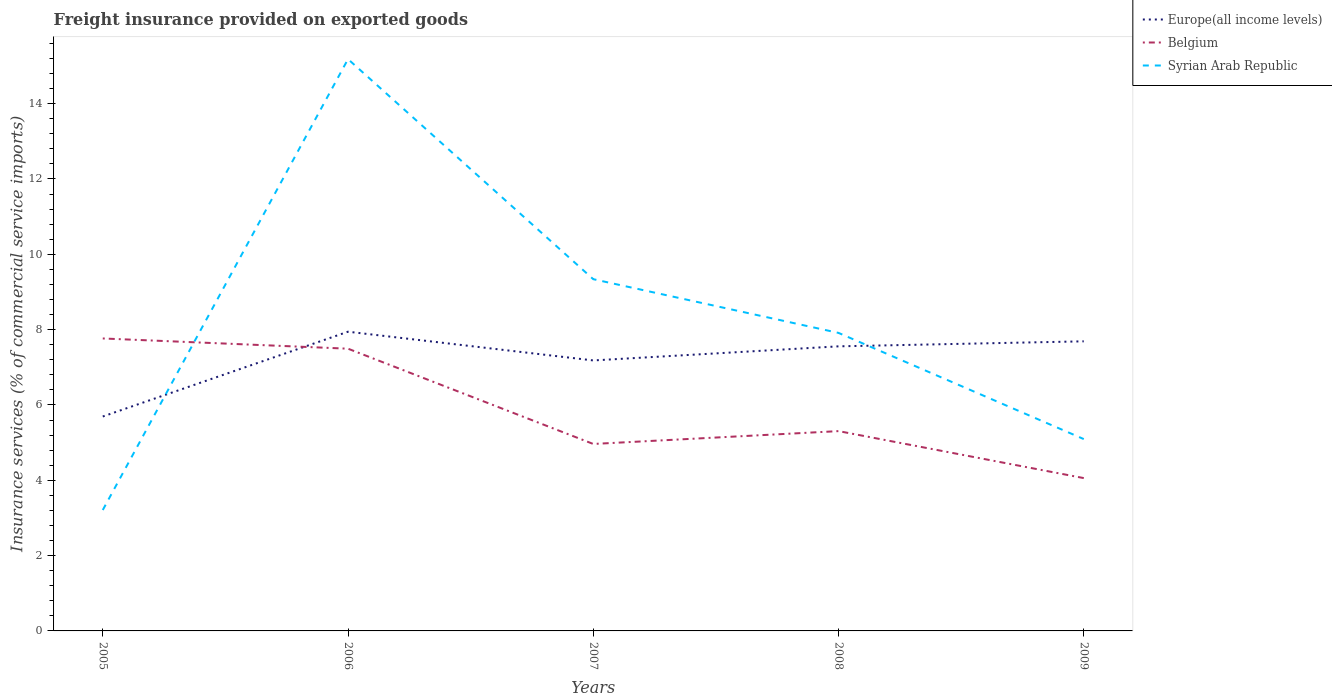How many different coloured lines are there?
Provide a short and direct response. 3. Does the line corresponding to Syrian Arab Republic intersect with the line corresponding to Belgium?
Your answer should be compact. Yes. Across all years, what is the maximum freight insurance provided on exported goods in Europe(all income levels)?
Offer a very short reply. 5.69. What is the total freight insurance provided on exported goods in Belgium in the graph?
Provide a succinct answer. 3.44. What is the difference between the highest and the second highest freight insurance provided on exported goods in Syrian Arab Republic?
Give a very brief answer. 11.97. Is the freight insurance provided on exported goods in Europe(all income levels) strictly greater than the freight insurance provided on exported goods in Syrian Arab Republic over the years?
Give a very brief answer. No. What is the difference between two consecutive major ticks on the Y-axis?
Your response must be concise. 2. Are the values on the major ticks of Y-axis written in scientific E-notation?
Give a very brief answer. No. Does the graph contain grids?
Keep it short and to the point. No. Where does the legend appear in the graph?
Your response must be concise. Top right. What is the title of the graph?
Provide a succinct answer. Freight insurance provided on exported goods. Does "Bangladesh" appear as one of the legend labels in the graph?
Your answer should be very brief. No. What is the label or title of the X-axis?
Your answer should be very brief. Years. What is the label or title of the Y-axis?
Ensure brevity in your answer.  Insurance services (% of commercial service imports). What is the Insurance services (% of commercial service imports) in Europe(all income levels) in 2005?
Give a very brief answer. 5.69. What is the Insurance services (% of commercial service imports) in Belgium in 2005?
Ensure brevity in your answer.  7.77. What is the Insurance services (% of commercial service imports) in Syrian Arab Republic in 2005?
Provide a succinct answer. 3.21. What is the Insurance services (% of commercial service imports) in Europe(all income levels) in 2006?
Offer a terse response. 7.94. What is the Insurance services (% of commercial service imports) in Belgium in 2006?
Offer a terse response. 7.49. What is the Insurance services (% of commercial service imports) in Syrian Arab Republic in 2006?
Your response must be concise. 15.18. What is the Insurance services (% of commercial service imports) of Europe(all income levels) in 2007?
Ensure brevity in your answer.  7.18. What is the Insurance services (% of commercial service imports) of Belgium in 2007?
Keep it short and to the point. 4.96. What is the Insurance services (% of commercial service imports) of Syrian Arab Republic in 2007?
Offer a very short reply. 9.34. What is the Insurance services (% of commercial service imports) in Europe(all income levels) in 2008?
Your answer should be very brief. 7.56. What is the Insurance services (% of commercial service imports) of Belgium in 2008?
Provide a short and direct response. 5.31. What is the Insurance services (% of commercial service imports) of Syrian Arab Republic in 2008?
Your response must be concise. 7.91. What is the Insurance services (% of commercial service imports) in Europe(all income levels) in 2009?
Your answer should be compact. 7.69. What is the Insurance services (% of commercial service imports) in Belgium in 2009?
Provide a succinct answer. 4.06. What is the Insurance services (% of commercial service imports) in Syrian Arab Republic in 2009?
Provide a succinct answer. 5.09. Across all years, what is the maximum Insurance services (% of commercial service imports) in Europe(all income levels)?
Your answer should be compact. 7.94. Across all years, what is the maximum Insurance services (% of commercial service imports) of Belgium?
Ensure brevity in your answer.  7.77. Across all years, what is the maximum Insurance services (% of commercial service imports) in Syrian Arab Republic?
Give a very brief answer. 15.18. Across all years, what is the minimum Insurance services (% of commercial service imports) in Europe(all income levels)?
Your answer should be very brief. 5.69. Across all years, what is the minimum Insurance services (% of commercial service imports) of Belgium?
Offer a terse response. 4.06. Across all years, what is the minimum Insurance services (% of commercial service imports) in Syrian Arab Republic?
Keep it short and to the point. 3.21. What is the total Insurance services (% of commercial service imports) in Europe(all income levels) in the graph?
Your answer should be compact. 36.07. What is the total Insurance services (% of commercial service imports) in Belgium in the graph?
Your answer should be compact. 29.59. What is the total Insurance services (% of commercial service imports) of Syrian Arab Republic in the graph?
Offer a very short reply. 40.74. What is the difference between the Insurance services (% of commercial service imports) of Europe(all income levels) in 2005 and that in 2006?
Give a very brief answer. -2.25. What is the difference between the Insurance services (% of commercial service imports) in Belgium in 2005 and that in 2006?
Offer a very short reply. 0.27. What is the difference between the Insurance services (% of commercial service imports) in Syrian Arab Republic in 2005 and that in 2006?
Provide a short and direct response. -11.97. What is the difference between the Insurance services (% of commercial service imports) of Europe(all income levels) in 2005 and that in 2007?
Provide a succinct answer. -1.49. What is the difference between the Insurance services (% of commercial service imports) in Belgium in 2005 and that in 2007?
Your response must be concise. 2.8. What is the difference between the Insurance services (% of commercial service imports) of Syrian Arab Republic in 2005 and that in 2007?
Offer a terse response. -6.13. What is the difference between the Insurance services (% of commercial service imports) in Europe(all income levels) in 2005 and that in 2008?
Ensure brevity in your answer.  -1.86. What is the difference between the Insurance services (% of commercial service imports) in Belgium in 2005 and that in 2008?
Your answer should be very brief. 2.46. What is the difference between the Insurance services (% of commercial service imports) of Syrian Arab Republic in 2005 and that in 2008?
Offer a terse response. -4.7. What is the difference between the Insurance services (% of commercial service imports) in Europe(all income levels) in 2005 and that in 2009?
Provide a short and direct response. -2. What is the difference between the Insurance services (% of commercial service imports) of Belgium in 2005 and that in 2009?
Make the answer very short. 3.71. What is the difference between the Insurance services (% of commercial service imports) in Syrian Arab Republic in 2005 and that in 2009?
Offer a very short reply. -1.88. What is the difference between the Insurance services (% of commercial service imports) in Europe(all income levels) in 2006 and that in 2007?
Offer a terse response. 0.76. What is the difference between the Insurance services (% of commercial service imports) of Belgium in 2006 and that in 2007?
Your answer should be compact. 2.53. What is the difference between the Insurance services (% of commercial service imports) of Syrian Arab Republic in 2006 and that in 2007?
Your answer should be compact. 5.84. What is the difference between the Insurance services (% of commercial service imports) of Europe(all income levels) in 2006 and that in 2008?
Offer a terse response. 0.39. What is the difference between the Insurance services (% of commercial service imports) in Belgium in 2006 and that in 2008?
Offer a terse response. 2.19. What is the difference between the Insurance services (% of commercial service imports) in Syrian Arab Republic in 2006 and that in 2008?
Offer a terse response. 7.27. What is the difference between the Insurance services (% of commercial service imports) of Europe(all income levels) in 2006 and that in 2009?
Your answer should be very brief. 0.26. What is the difference between the Insurance services (% of commercial service imports) in Belgium in 2006 and that in 2009?
Your answer should be compact. 3.44. What is the difference between the Insurance services (% of commercial service imports) of Syrian Arab Republic in 2006 and that in 2009?
Offer a very short reply. 10.09. What is the difference between the Insurance services (% of commercial service imports) of Europe(all income levels) in 2007 and that in 2008?
Your answer should be very brief. -0.37. What is the difference between the Insurance services (% of commercial service imports) in Belgium in 2007 and that in 2008?
Your answer should be compact. -0.34. What is the difference between the Insurance services (% of commercial service imports) of Syrian Arab Republic in 2007 and that in 2008?
Your answer should be very brief. 1.43. What is the difference between the Insurance services (% of commercial service imports) of Europe(all income levels) in 2007 and that in 2009?
Give a very brief answer. -0.51. What is the difference between the Insurance services (% of commercial service imports) of Belgium in 2007 and that in 2009?
Give a very brief answer. 0.91. What is the difference between the Insurance services (% of commercial service imports) in Syrian Arab Republic in 2007 and that in 2009?
Your answer should be very brief. 4.25. What is the difference between the Insurance services (% of commercial service imports) in Europe(all income levels) in 2008 and that in 2009?
Make the answer very short. -0.13. What is the difference between the Insurance services (% of commercial service imports) in Belgium in 2008 and that in 2009?
Offer a very short reply. 1.25. What is the difference between the Insurance services (% of commercial service imports) in Syrian Arab Republic in 2008 and that in 2009?
Make the answer very short. 2.82. What is the difference between the Insurance services (% of commercial service imports) of Europe(all income levels) in 2005 and the Insurance services (% of commercial service imports) of Belgium in 2006?
Provide a short and direct response. -1.8. What is the difference between the Insurance services (% of commercial service imports) in Europe(all income levels) in 2005 and the Insurance services (% of commercial service imports) in Syrian Arab Republic in 2006?
Offer a very short reply. -9.49. What is the difference between the Insurance services (% of commercial service imports) in Belgium in 2005 and the Insurance services (% of commercial service imports) in Syrian Arab Republic in 2006?
Keep it short and to the point. -7.42. What is the difference between the Insurance services (% of commercial service imports) in Europe(all income levels) in 2005 and the Insurance services (% of commercial service imports) in Belgium in 2007?
Offer a terse response. 0.73. What is the difference between the Insurance services (% of commercial service imports) of Europe(all income levels) in 2005 and the Insurance services (% of commercial service imports) of Syrian Arab Republic in 2007?
Give a very brief answer. -3.65. What is the difference between the Insurance services (% of commercial service imports) of Belgium in 2005 and the Insurance services (% of commercial service imports) of Syrian Arab Republic in 2007?
Provide a succinct answer. -1.57. What is the difference between the Insurance services (% of commercial service imports) in Europe(all income levels) in 2005 and the Insurance services (% of commercial service imports) in Belgium in 2008?
Provide a short and direct response. 0.39. What is the difference between the Insurance services (% of commercial service imports) in Europe(all income levels) in 2005 and the Insurance services (% of commercial service imports) in Syrian Arab Republic in 2008?
Your answer should be compact. -2.22. What is the difference between the Insurance services (% of commercial service imports) of Belgium in 2005 and the Insurance services (% of commercial service imports) of Syrian Arab Republic in 2008?
Your answer should be very brief. -0.15. What is the difference between the Insurance services (% of commercial service imports) in Europe(all income levels) in 2005 and the Insurance services (% of commercial service imports) in Belgium in 2009?
Keep it short and to the point. 1.64. What is the difference between the Insurance services (% of commercial service imports) of Europe(all income levels) in 2005 and the Insurance services (% of commercial service imports) of Syrian Arab Republic in 2009?
Keep it short and to the point. 0.6. What is the difference between the Insurance services (% of commercial service imports) in Belgium in 2005 and the Insurance services (% of commercial service imports) in Syrian Arab Republic in 2009?
Offer a terse response. 2.67. What is the difference between the Insurance services (% of commercial service imports) in Europe(all income levels) in 2006 and the Insurance services (% of commercial service imports) in Belgium in 2007?
Give a very brief answer. 2.98. What is the difference between the Insurance services (% of commercial service imports) in Europe(all income levels) in 2006 and the Insurance services (% of commercial service imports) in Syrian Arab Republic in 2007?
Keep it short and to the point. -1.39. What is the difference between the Insurance services (% of commercial service imports) of Belgium in 2006 and the Insurance services (% of commercial service imports) of Syrian Arab Republic in 2007?
Ensure brevity in your answer.  -1.85. What is the difference between the Insurance services (% of commercial service imports) in Europe(all income levels) in 2006 and the Insurance services (% of commercial service imports) in Belgium in 2008?
Your answer should be very brief. 2.64. What is the difference between the Insurance services (% of commercial service imports) in Europe(all income levels) in 2006 and the Insurance services (% of commercial service imports) in Syrian Arab Republic in 2008?
Keep it short and to the point. 0.03. What is the difference between the Insurance services (% of commercial service imports) of Belgium in 2006 and the Insurance services (% of commercial service imports) of Syrian Arab Republic in 2008?
Make the answer very short. -0.42. What is the difference between the Insurance services (% of commercial service imports) in Europe(all income levels) in 2006 and the Insurance services (% of commercial service imports) in Belgium in 2009?
Your answer should be compact. 3.89. What is the difference between the Insurance services (% of commercial service imports) of Europe(all income levels) in 2006 and the Insurance services (% of commercial service imports) of Syrian Arab Republic in 2009?
Your answer should be very brief. 2.85. What is the difference between the Insurance services (% of commercial service imports) of Belgium in 2006 and the Insurance services (% of commercial service imports) of Syrian Arab Republic in 2009?
Your answer should be compact. 2.4. What is the difference between the Insurance services (% of commercial service imports) of Europe(all income levels) in 2007 and the Insurance services (% of commercial service imports) of Belgium in 2008?
Your response must be concise. 1.88. What is the difference between the Insurance services (% of commercial service imports) in Europe(all income levels) in 2007 and the Insurance services (% of commercial service imports) in Syrian Arab Republic in 2008?
Provide a short and direct response. -0.73. What is the difference between the Insurance services (% of commercial service imports) in Belgium in 2007 and the Insurance services (% of commercial service imports) in Syrian Arab Republic in 2008?
Provide a short and direct response. -2.95. What is the difference between the Insurance services (% of commercial service imports) of Europe(all income levels) in 2007 and the Insurance services (% of commercial service imports) of Belgium in 2009?
Offer a terse response. 3.12. What is the difference between the Insurance services (% of commercial service imports) in Europe(all income levels) in 2007 and the Insurance services (% of commercial service imports) in Syrian Arab Republic in 2009?
Your response must be concise. 2.09. What is the difference between the Insurance services (% of commercial service imports) in Belgium in 2007 and the Insurance services (% of commercial service imports) in Syrian Arab Republic in 2009?
Your response must be concise. -0.13. What is the difference between the Insurance services (% of commercial service imports) in Europe(all income levels) in 2008 and the Insurance services (% of commercial service imports) in Belgium in 2009?
Provide a succinct answer. 3.5. What is the difference between the Insurance services (% of commercial service imports) of Europe(all income levels) in 2008 and the Insurance services (% of commercial service imports) of Syrian Arab Republic in 2009?
Give a very brief answer. 2.46. What is the difference between the Insurance services (% of commercial service imports) in Belgium in 2008 and the Insurance services (% of commercial service imports) in Syrian Arab Republic in 2009?
Provide a succinct answer. 0.21. What is the average Insurance services (% of commercial service imports) in Europe(all income levels) per year?
Your response must be concise. 7.21. What is the average Insurance services (% of commercial service imports) in Belgium per year?
Your response must be concise. 5.92. What is the average Insurance services (% of commercial service imports) in Syrian Arab Republic per year?
Ensure brevity in your answer.  8.15. In the year 2005, what is the difference between the Insurance services (% of commercial service imports) of Europe(all income levels) and Insurance services (% of commercial service imports) of Belgium?
Offer a terse response. -2.07. In the year 2005, what is the difference between the Insurance services (% of commercial service imports) in Europe(all income levels) and Insurance services (% of commercial service imports) in Syrian Arab Republic?
Make the answer very short. 2.48. In the year 2005, what is the difference between the Insurance services (% of commercial service imports) of Belgium and Insurance services (% of commercial service imports) of Syrian Arab Republic?
Make the answer very short. 4.56. In the year 2006, what is the difference between the Insurance services (% of commercial service imports) in Europe(all income levels) and Insurance services (% of commercial service imports) in Belgium?
Provide a short and direct response. 0.45. In the year 2006, what is the difference between the Insurance services (% of commercial service imports) in Europe(all income levels) and Insurance services (% of commercial service imports) in Syrian Arab Republic?
Make the answer very short. -7.24. In the year 2006, what is the difference between the Insurance services (% of commercial service imports) of Belgium and Insurance services (% of commercial service imports) of Syrian Arab Republic?
Your response must be concise. -7.69. In the year 2007, what is the difference between the Insurance services (% of commercial service imports) of Europe(all income levels) and Insurance services (% of commercial service imports) of Belgium?
Your response must be concise. 2.22. In the year 2007, what is the difference between the Insurance services (% of commercial service imports) in Europe(all income levels) and Insurance services (% of commercial service imports) in Syrian Arab Republic?
Provide a short and direct response. -2.16. In the year 2007, what is the difference between the Insurance services (% of commercial service imports) in Belgium and Insurance services (% of commercial service imports) in Syrian Arab Republic?
Offer a very short reply. -4.38. In the year 2008, what is the difference between the Insurance services (% of commercial service imports) in Europe(all income levels) and Insurance services (% of commercial service imports) in Belgium?
Ensure brevity in your answer.  2.25. In the year 2008, what is the difference between the Insurance services (% of commercial service imports) in Europe(all income levels) and Insurance services (% of commercial service imports) in Syrian Arab Republic?
Give a very brief answer. -0.36. In the year 2008, what is the difference between the Insurance services (% of commercial service imports) in Belgium and Insurance services (% of commercial service imports) in Syrian Arab Republic?
Give a very brief answer. -2.61. In the year 2009, what is the difference between the Insurance services (% of commercial service imports) in Europe(all income levels) and Insurance services (% of commercial service imports) in Belgium?
Your answer should be very brief. 3.63. In the year 2009, what is the difference between the Insurance services (% of commercial service imports) of Europe(all income levels) and Insurance services (% of commercial service imports) of Syrian Arab Republic?
Provide a short and direct response. 2.6. In the year 2009, what is the difference between the Insurance services (% of commercial service imports) in Belgium and Insurance services (% of commercial service imports) in Syrian Arab Republic?
Offer a very short reply. -1.04. What is the ratio of the Insurance services (% of commercial service imports) of Europe(all income levels) in 2005 to that in 2006?
Give a very brief answer. 0.72. What is the ratio of the Insurance services (% of commercial service imports) in Belgium in 2005 to that in 2006?
Give a very brief answer. 1.04. What is the ratio of the Insurance services (% of commercial service imports) of Syrian Arab Republic in 2005 to that in 2006?
Provide a succinct answer. 0.21. What is the ratio of the Insurance services (% of commercial service imports) in Europe(all income levels) in 2005 to that in 2007?
Your answer should be compact. 0.79. What is the ratio of the Insurance services (% of commercial service imports) in Belgium in 2005 to that in 2007?
Provide a succinct answer. 1.56. What is the ratio of the Insurance services (% of commercial service imports) in Syrian Arab Republic in 2005 to that in 2007?
Your answer should be compact. 0.34. What is the ratio of the Insurance services (% of commercial service imports) of Europe(all income levels) in 2005 to that in 2008?
Offer a very short reply. 0.75. What is the ratio of the Insurance services (% of commercial service imports) in Belgium in 2005 to that in 2008?
Provide a succinct answer. 1.46. What is the ratio of the Insurance services (% of commercial service imports) of Syrian Arab Republic in 2005 to that in 2008?
Provide a succinct answer. 0.41. What is the ratio of the Insurance services (% of commercial service imports) in Europe(all income levels) in 2005 to that in 2009?
Your answer should be compact. 0.74. What is the ratio of the Insurance services (% of commercial service imports) in Belgium in 2005 to that in 2009?
Your answer should be very brief. 1.91. What is the ratio of the Insurance services (% of commercial service imports) in Syrian Arab Republic in 2005 to that in 2009?
Your answer should be compact. 0.63. What is the ratio of the Insurance services (% of commercial service imports) of Europe(all income levels) in 2006 to that in 2007?
Your answer should be compact. 1.11. What is the ratio of the Insurance services (% of commercial service imports) in Belgium in 2006 to that in 2007?
Give a very brief answer. 1.51. What is the ratio of the Insurance services (% of commercial service imports) in Syrian Arab Republic in 2006 to that in 2007?
Keep it short and to the point. 1.63. What is the ratio of the Insurance services (% of commercial service imports) of Europe(all income levels) in 2006 to that in 2008?
Make the answer very short. 1.05. What is the ratio of the Insurance services (% of commercial service imports) of Belgium in 2006 to that in 2008?
Provide a succinct answer. 1.41. What is the ratio of the Insurance services (% of commercial service imports) in Syrian Arab Republic in 2006 to that in 2008?
Provide a short and direct response. 1.92. What is the ratio of the Insurance services (% of commercial service imports) in Europe(all income levels) in 2006 to that in 2009?
Ensure brevity in your answer.  1.03. What is the ratio of the Insurance services (% of commercial service imports) in Belgium in 2006 to that in 2009?
Make the answer very short. 1.85. What is the ratio of the Insurance services (% of commercial service imports) in Syrian Arab Republic in 2006 to that in 2009?
Provide a succinct answer. 2.98. What is the ratio of the Insurance services (% of commercial service imports) of Europe(all income levels) in 2007 to that in 2008?
Give a very brief answer. 0.95. What is the ratio of the Insurance services (% of commercial service imports) in Belgium in 2007 to that in 2008?
Provide a succinct answer. 0.94. What is the ratio of the Insurance services (% of commercial service imports) in Syrian Arab Republic in 2007 to that in 2008?
Ensure brevity in your answer.  1.18. What is the ratio of the Insurance services (% of commercial service imports) in Europe(all income levels) in 2007 to that in 2009?
Your response must be concise. 0.93. What is the ratio of the Insurance services (% of commercial service imports) in Belgium in 2007 to that in 2009?
Offer a terse response. 1.22. What is the ratio of the Insurance services (% of commercial service imports) in Syrian Arab Republic in 2007 to that in 2009?
Offer a terse response. 1.83. What is the ratio of the Insurance services (% of commercial service imports) in Europe(all income levels) in 2008 to that in 2009?
Your answer should be very brief. 0.98. What is the ratio of the Insurance services (% of commercial service imports) in Belgium in 2008 to that in 2009?
Offer a terse response. 1.31. What is the ratio of the Insurance services (% of commercial service imports) in Syrian Arab Republic in 2008 to that in 2009?
Make the answer very short. 1.55. What is the difference between the highest and the second highest Insurance services (% of commercial service imports) in Europe(all income levels)?
Your answer should be very brief. 0.26. What is the difference between the highest and the second highest Insurance services (% of commercial service imports) in Belgium?
Give a very brief answer. 0.27. What is the difference between the highest and the second highest Insurance services (% of commercial service imports) of Syrian Arab Republic?
Give a very brief answer. 5.84. What is the difference between the highest and the lowest Insurance services (% of commercial service imports) of Europe(all income levels)?
Your answer should be compact. 2.25. What is the difference between the highest and the lowest Insurance services (% of commercial service imports) of Belgium?
Your response must be concise. 3.71. What is the difference between the highest and the lowest Insurance services (% of commercial service imports) of Syrian Arab Republic?
Offer a terse response. 11.97. 